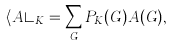<formula> <loc_0><loc_0><loc_500><loc_500>\langle A \rangle _ { K } = \sum _ { G } P _ { K } ( G ) A ( G ) ,</formula> 